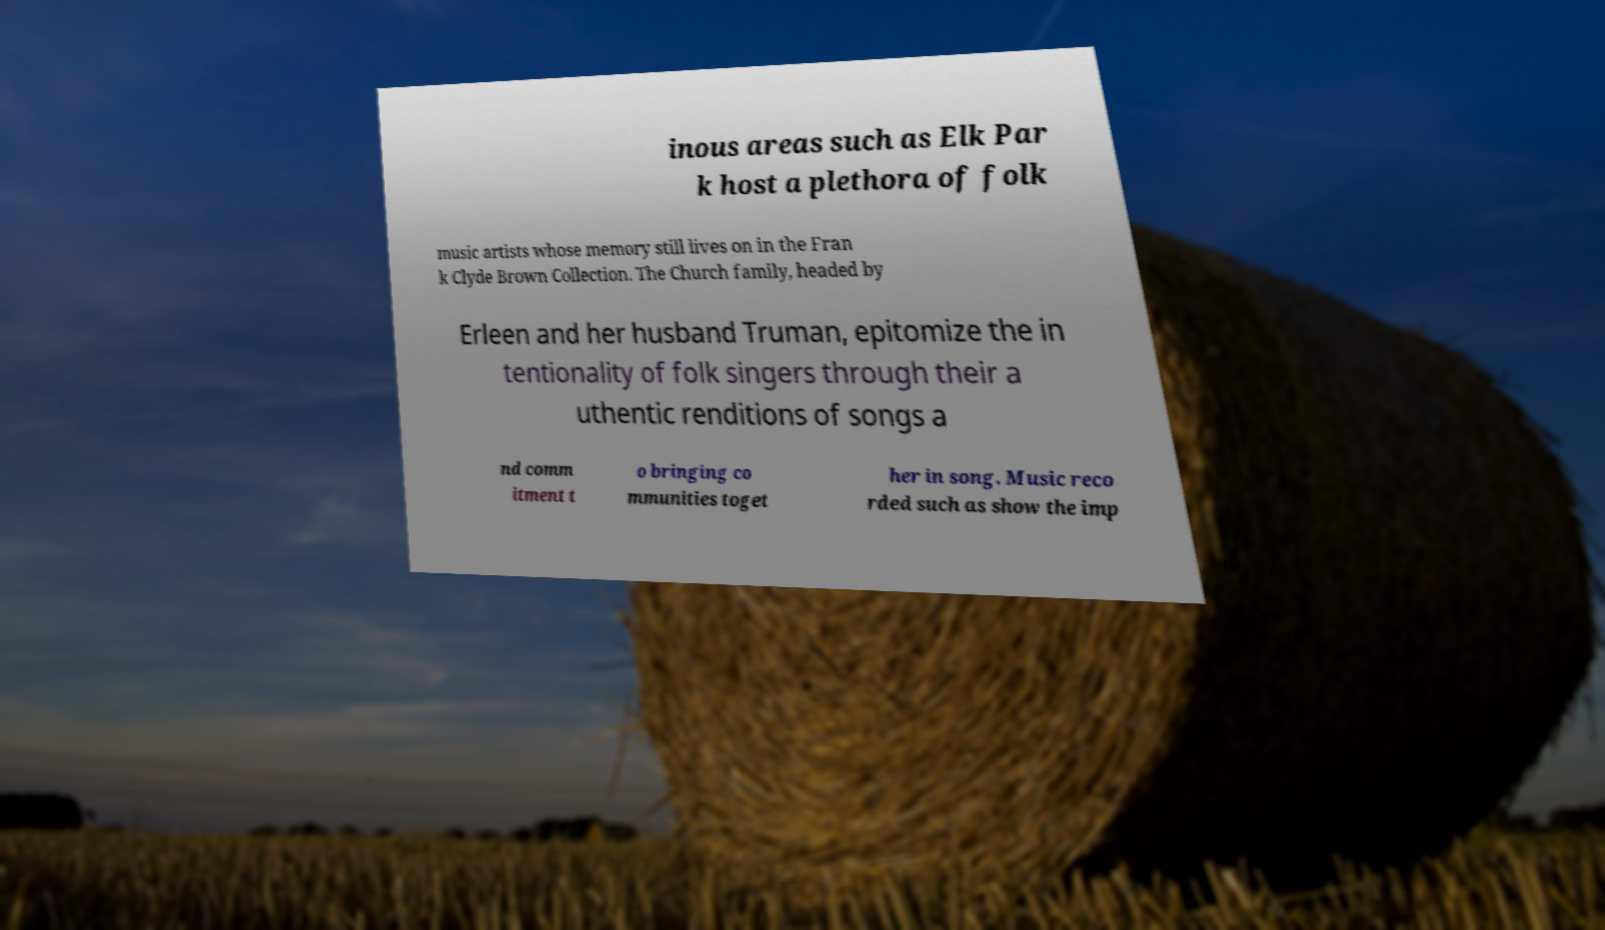What messages or text are displayed in this image? I need them in a readable, typed format. inous areas such as Elk Par k host a plethora of folk music artists whose memory still lives on in the Fran k Clyde Brown Collection. The Church family, headed by Erleen and her husband Truman, epitomize the in tentionality of folk singers through their a uthentic renditions of songs a nd comm itment t o bringing co mmunities toget her in song. Music reco rded such as show the imp 